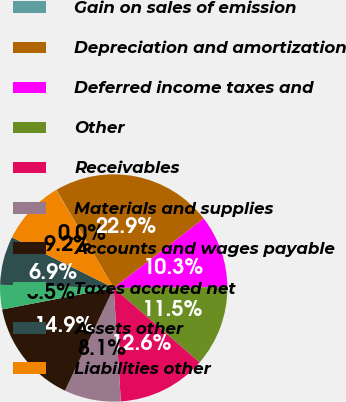Convert chart. <chart><loc_0><loc_0><loc_500><loc_500><pie_chart><fcel>Gain on sales of emission<fcel>Depreciation and amortization<fcel>Deferred income taxes and<fcel>Other<fcel>Receivables<fcel>Materials and supplies<fcel>Accounts and wages payable<fcel>Taxes accrued net<fcel>Assets other<fcel>Liabilities other<nl><fcel>0.04%<fcel>22.94%<fcel>10.34%<fcel>11.49%<fcel>12.63%<fcel>8.05%<fcel>14.92%<fcel>3.47%<fcel>6.91%<fcel>9.2%<nl></chart> 